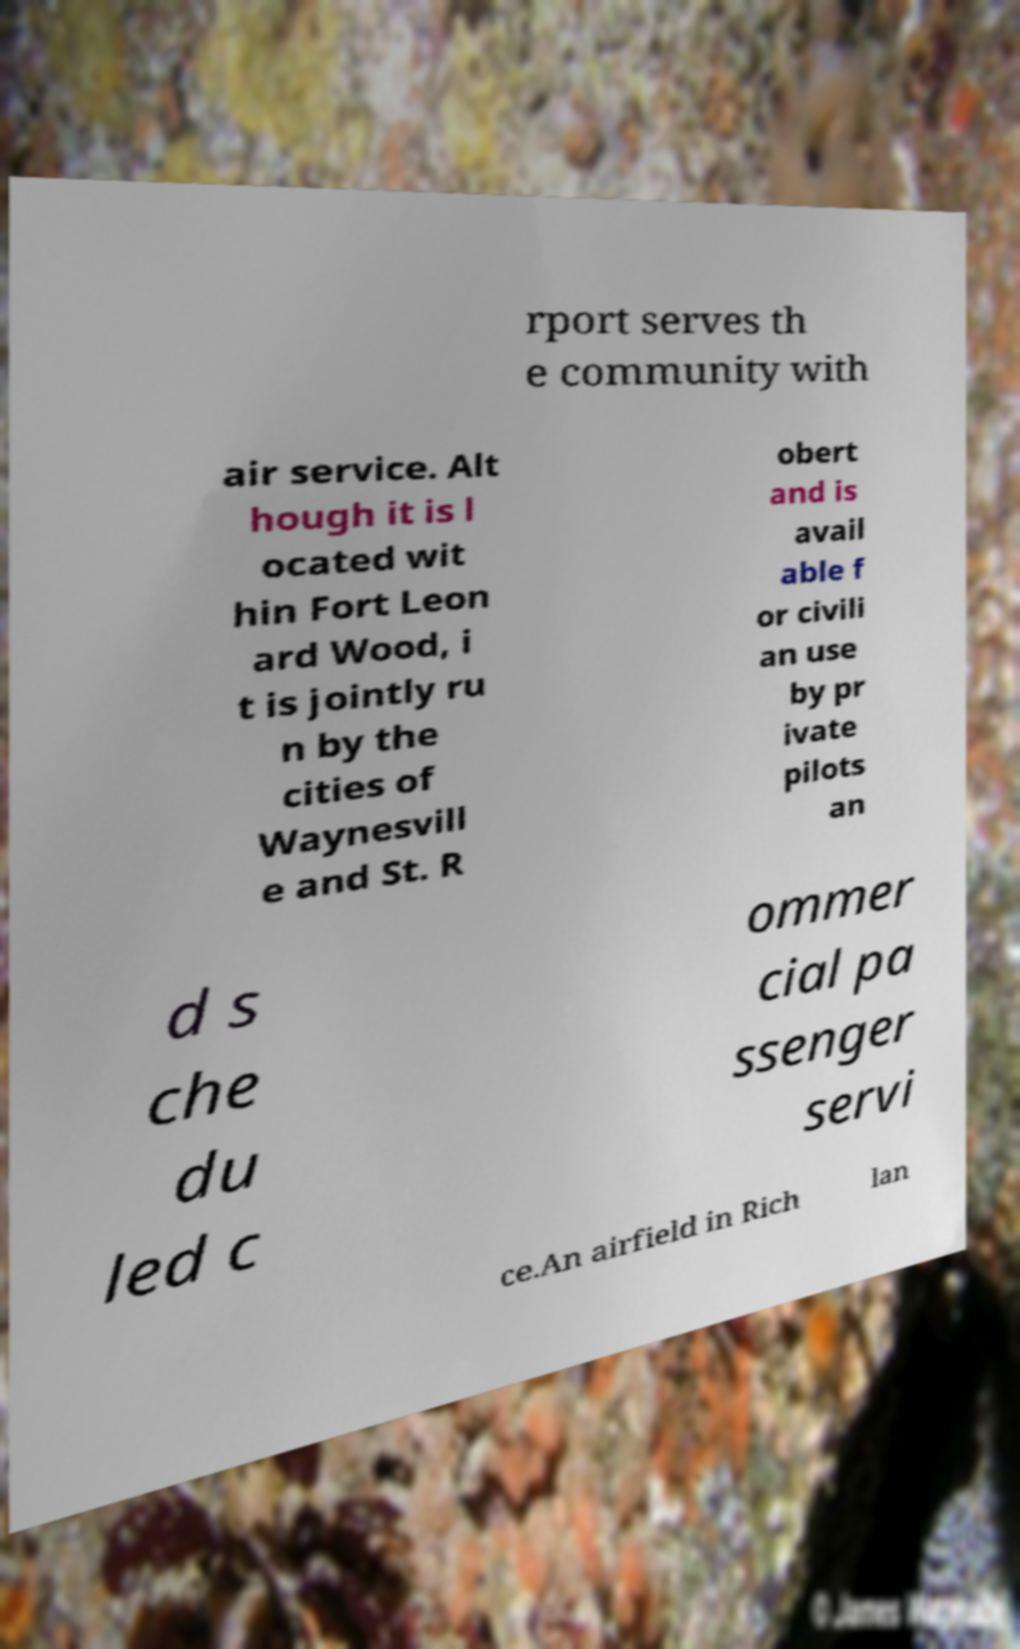There's text embedded in this image that I need extracted. Can you transcribe it verbatim? rport serves th e community with air service. Alt hough it is l ocated wit hin Fort Leon ard Wood, i t is jointly ru n by the cities of Waynesvill e and St. R obert and is avail able f or civili an use by pr ivate pilots an d s che du led c ommer cial pa ssenger servi ce.An airfield in Rich lan 